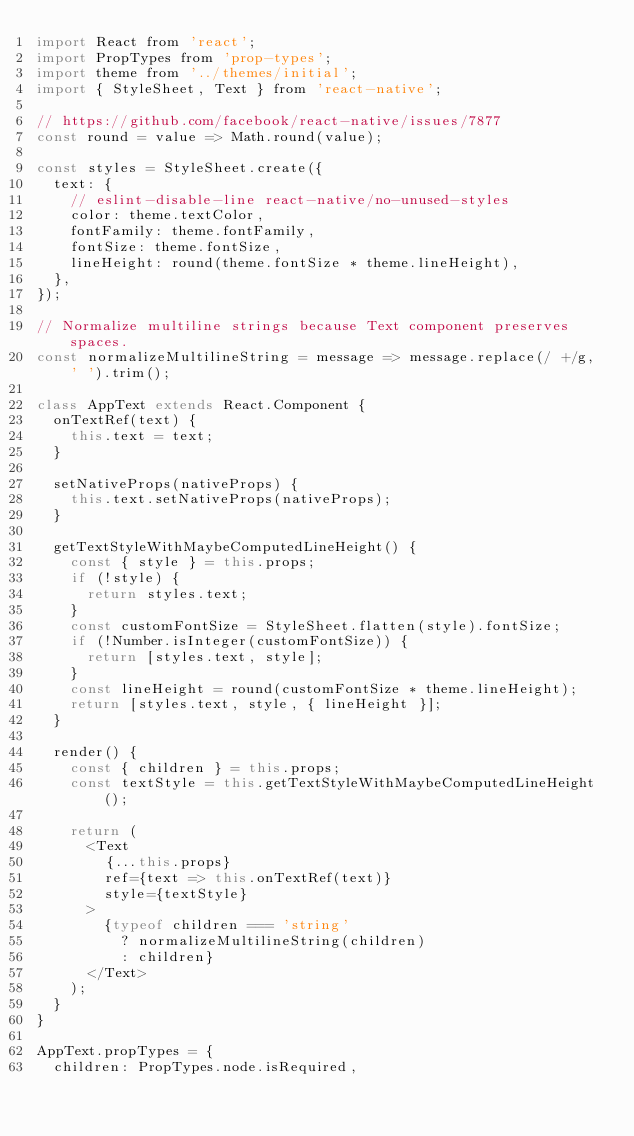Convert code to text. <code><loc_0><loc_0><loc_500><loc_500><_JavaScript_>import React from 'react';
import PropTypes from 'prop-types';
import theme from '../themes/initial';
import { StyleSheet, Text } from 'react-native';

// https://github.com/facebook/react-native/issues/7877
const round = value => Math.round(value);

const styles = StyleSheet.create({
  text: {
    // eslint-disable-line react-native/no-unused-styles
    color: theme.textColor,
    fontFamily: theme.fontFamily,
    fontSize: theme.fontSize,
    lineHeight: round(theme.fontSize * theme.lineHeight),
  },
});

// Normalize multiline strings because Text component preserves spaces.
const normalizeMultilineString = message => message.replace(/ +/g, ' ').trim();

class AppText extends React.Component {
  onTextRef(text) {
    this.text = text;
  }

  setNativeProps(nativeProps) {
    this.text.setNativeProps(nativeProps);
  }

  getTextStyleWithMaybeComputedLineHeight() {
    const { style } = this.props;
    if (!style) {
      return styles.text;
    }
    const customFontSize = StyleSheet.flatten(style).fontSize;
    if (!Number.isInteger(customFontSize)) {
      return [styles.text, style];
    }
    const lineHeight = round(customFontSize * theme.lineHeight);
    return [styles.text, style, { lineHeight }];
  }

  render() {
    const { children } = this.props;
    const textStyle = this.getTextStyleWithMaybeComputedLineHeight();

    return (
      <Text
        {...this.props}
        ref={text => this.onTextRef(text)}
        style={textStyle}
      >
        {typeof children === 'string'
          ? normalizeMultilineString(children)
          : children}
      </Text>
    );
  }
}

AppText.propTypes = {
  children: PropTypes.node.isRequired,</code> 